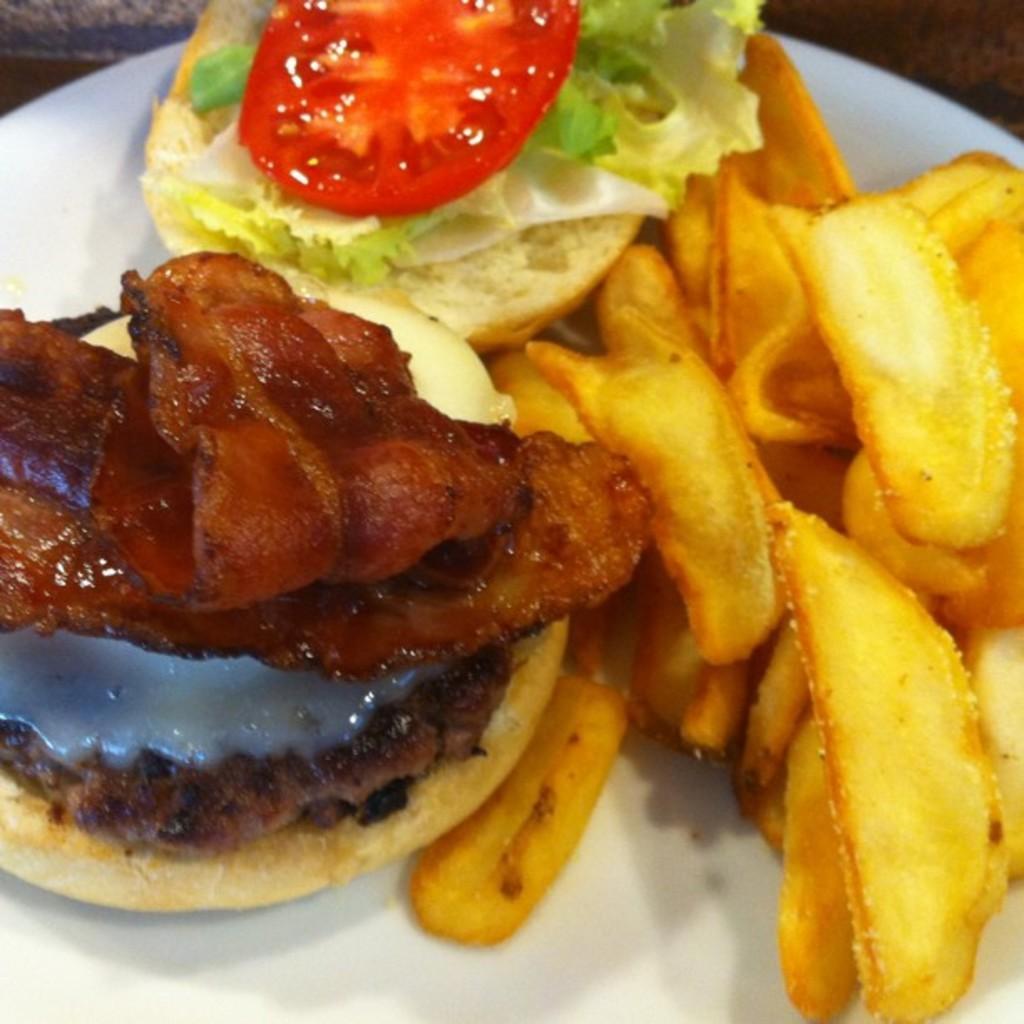How would you summarize this image in a sentence or two? In the image we can see a plate, in the plate we can see some food. 